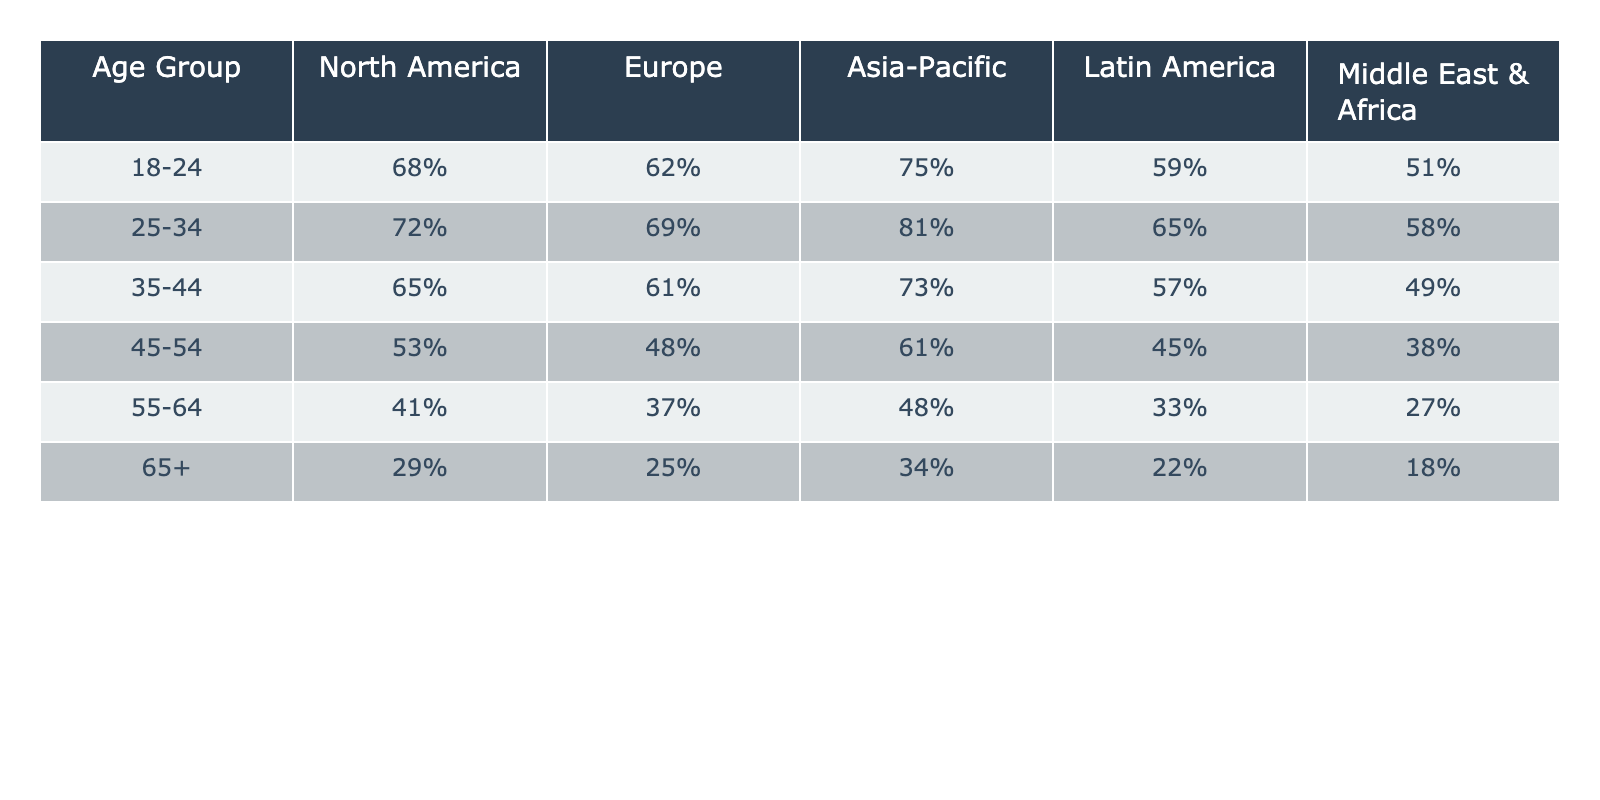What is the user adoption rate for the 25-34 age group in Asia-Pacific? The table shows that the adoption rate for the 25-34 age group in Asia-Pacific is 81%.
Answer: 81% Which age group has the highest user adoption rate in Europe? According to the table, the 25-34 age group has the highest adoption rate in Europe at 69%.
Answer: 69% Are user adoption rates higher in North America for the 55-64 age group compared to the 45-54 age group? The table indicates that the adoption rate for the 55-64 age group in North America is 41%, while for the 45-54 age group it is 53%. Since 53% > 41%, the statement is false.
Answer: No What is the difference in user adoption rates between the 18-24 age group and the 65+ age group in Latin America? In Latin America, the adoption rate for the 18-24 age group is 59%, and for the 65+ age group, it is 22%. The difference is calculated as 59% - 22% = 37%.
Answer: 37% What is the average user adoption rate across all age groups in the Middle East & Africa? The adoption rates in the Middle East & Africa are 51%, 58%, 49%, 38%, 27%, and 18% for the respective age groups. First, sum these rates: 51 + 58 + 49 + 38 + 27 + 18 = 241. Then, divide by the number of age groups (6) to get the average: 241 / 6 ≈ 40.17%.
Answer: 40.17% Which region has the lowest user adoption rate for the 55-64 age group? The table shows that the 55-64 age group has the lowest adoption rate in the Middle East & Africa at 27%.
Answer: 27% What is the trend in user adoption rates for older age groups (55-64 and 65+) across all regions? Looking at the table, the adoption rates for both the 55-64 and 65+ age groups generally decline as the age increases across all regions, indicating a downward trend in user adoption for older age groups.
Answer: Downward trend Is the user adoption rate for the 35-44 age group in Asia-Pacific higher than the rate for the 18-24 age group in North America? The adoption rate for the 35-44 age group in Asia-Pacific is 73%, while for the 18-24 age group in North America it is 68%. Since 73% > 68%, the statement is true.
Answer: Yes 